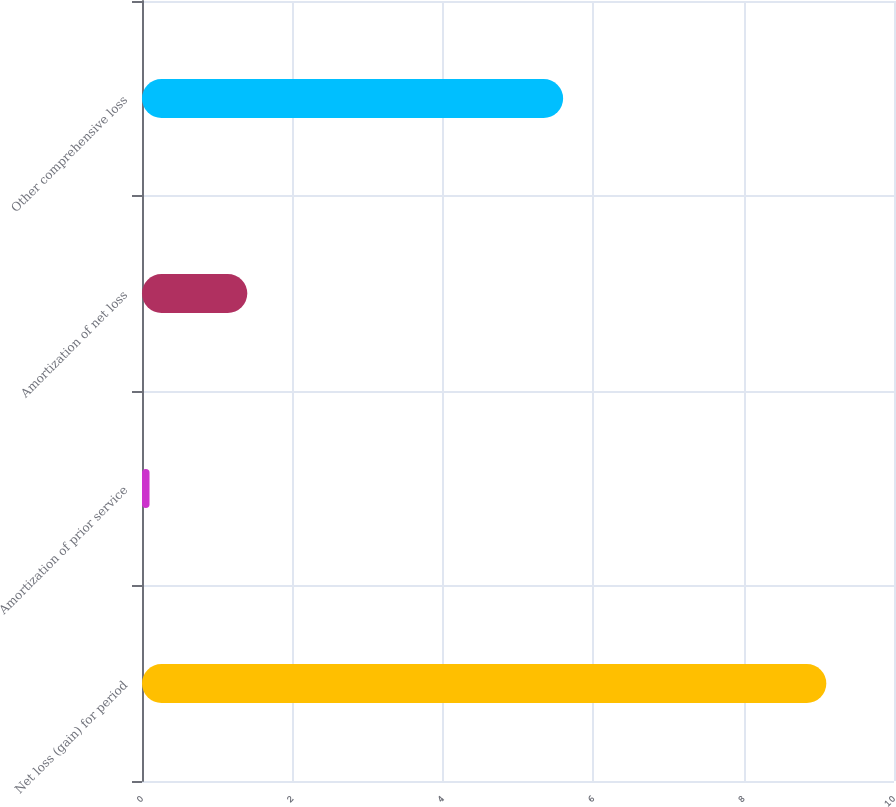Convert chart to OTSL. <chart><loc_0><loc_0><loc_500><loc_500><bar_chart><fcel>Net loss (gain) for period<fcel>Amortization of prior service<fcel>Amortization of net loss<fcel>Other comprehensive loss<nl><fcel>9.1<fcel>0.1<fcel>1.4<fcel>5.6<nl></chart> 